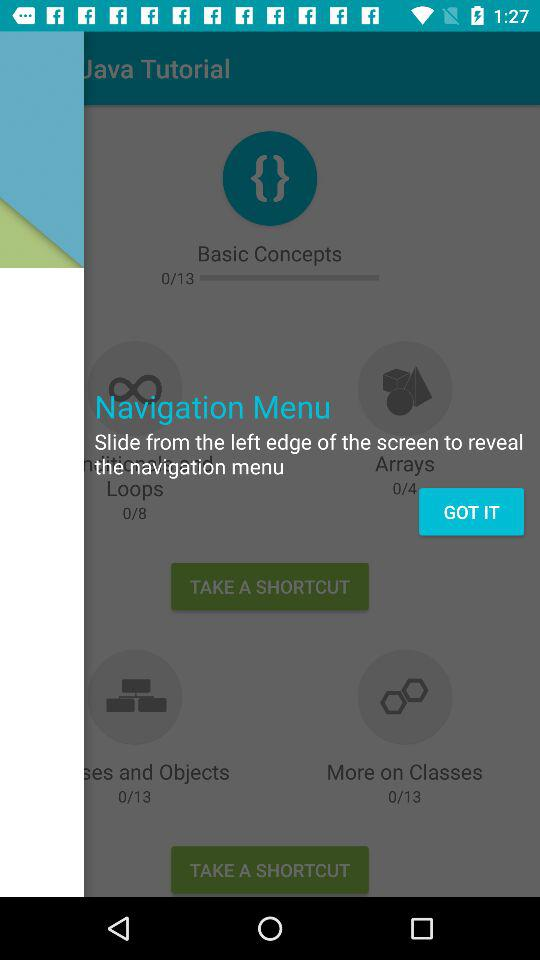What should we do to reveal the navigation menu? You should slide from the left edge of the screen to reveal the navigation menu. 